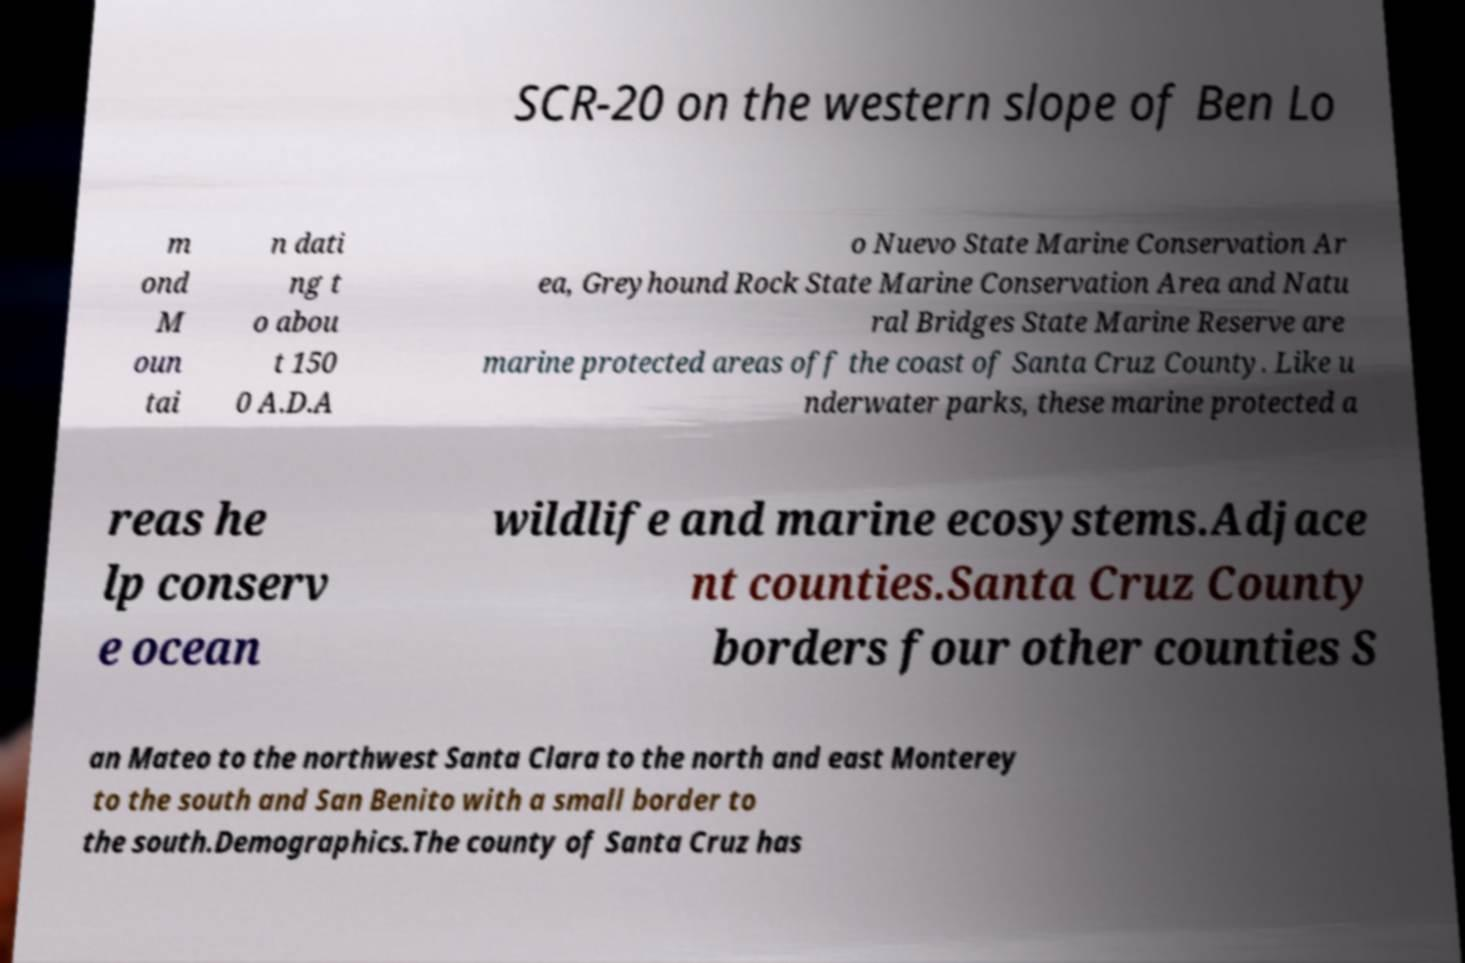Could you extract and type out the text from this image? SCR-20 on the western slope of Ben Lo m ond M oun tai n dati ng t o abou t 150 0 A.D.A o Nuevo State Marine Conservation Ar ea, Greyhound Rock State Marine Conservation Area and Natu ral Bridges State Marine Reserve are marine protected areas off the coast of Santa Cruz County. Like u nderwater parks, these marine protected a reas he lp conserv e ocean wildlife and marine ecosystems.Adjace nt counties.Santa Cruz County borders four other counties S an Mateo to the northwest Santa Clara to the north and east Monterey to the south and San Benito with a small border to the south.Demographics.The county of Santa Cruz has 